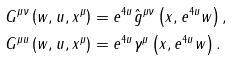<formula> <loc_0><loc_0><loc_500><loc_500>G ^ { \mu \nu } \left ( w , u , x ^ { \mu } \right ) & = e ^ { 4 u } \hat { g } ^ { \mu \nu } \left ( x , e ^ { 4 u } w \right ) , \, \\ G ^ { \mu u } \left ( w , u , x ^ { \mu } \right ) & = e ^ { 4 u } \gamma ^ { \mu } \left ( x , e ^ { 4 u } w \right ) .</formula> 